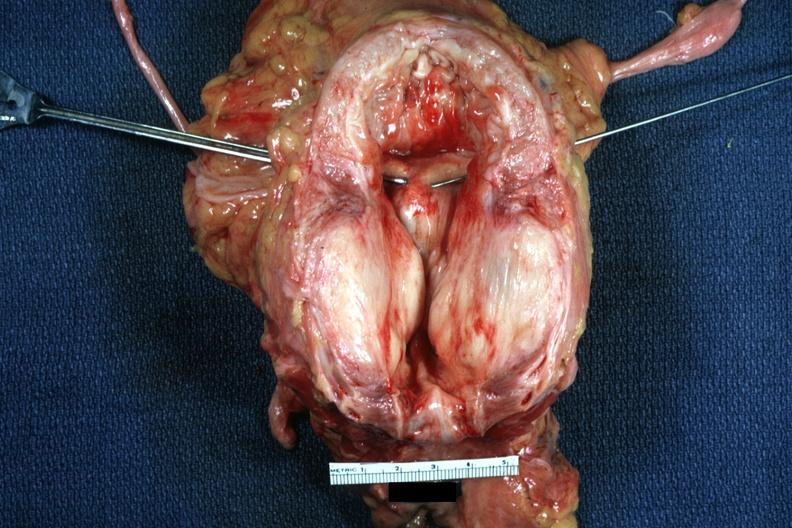what is large gland hypertrophied?
Answer the question using a single word or phrase. Bladder 